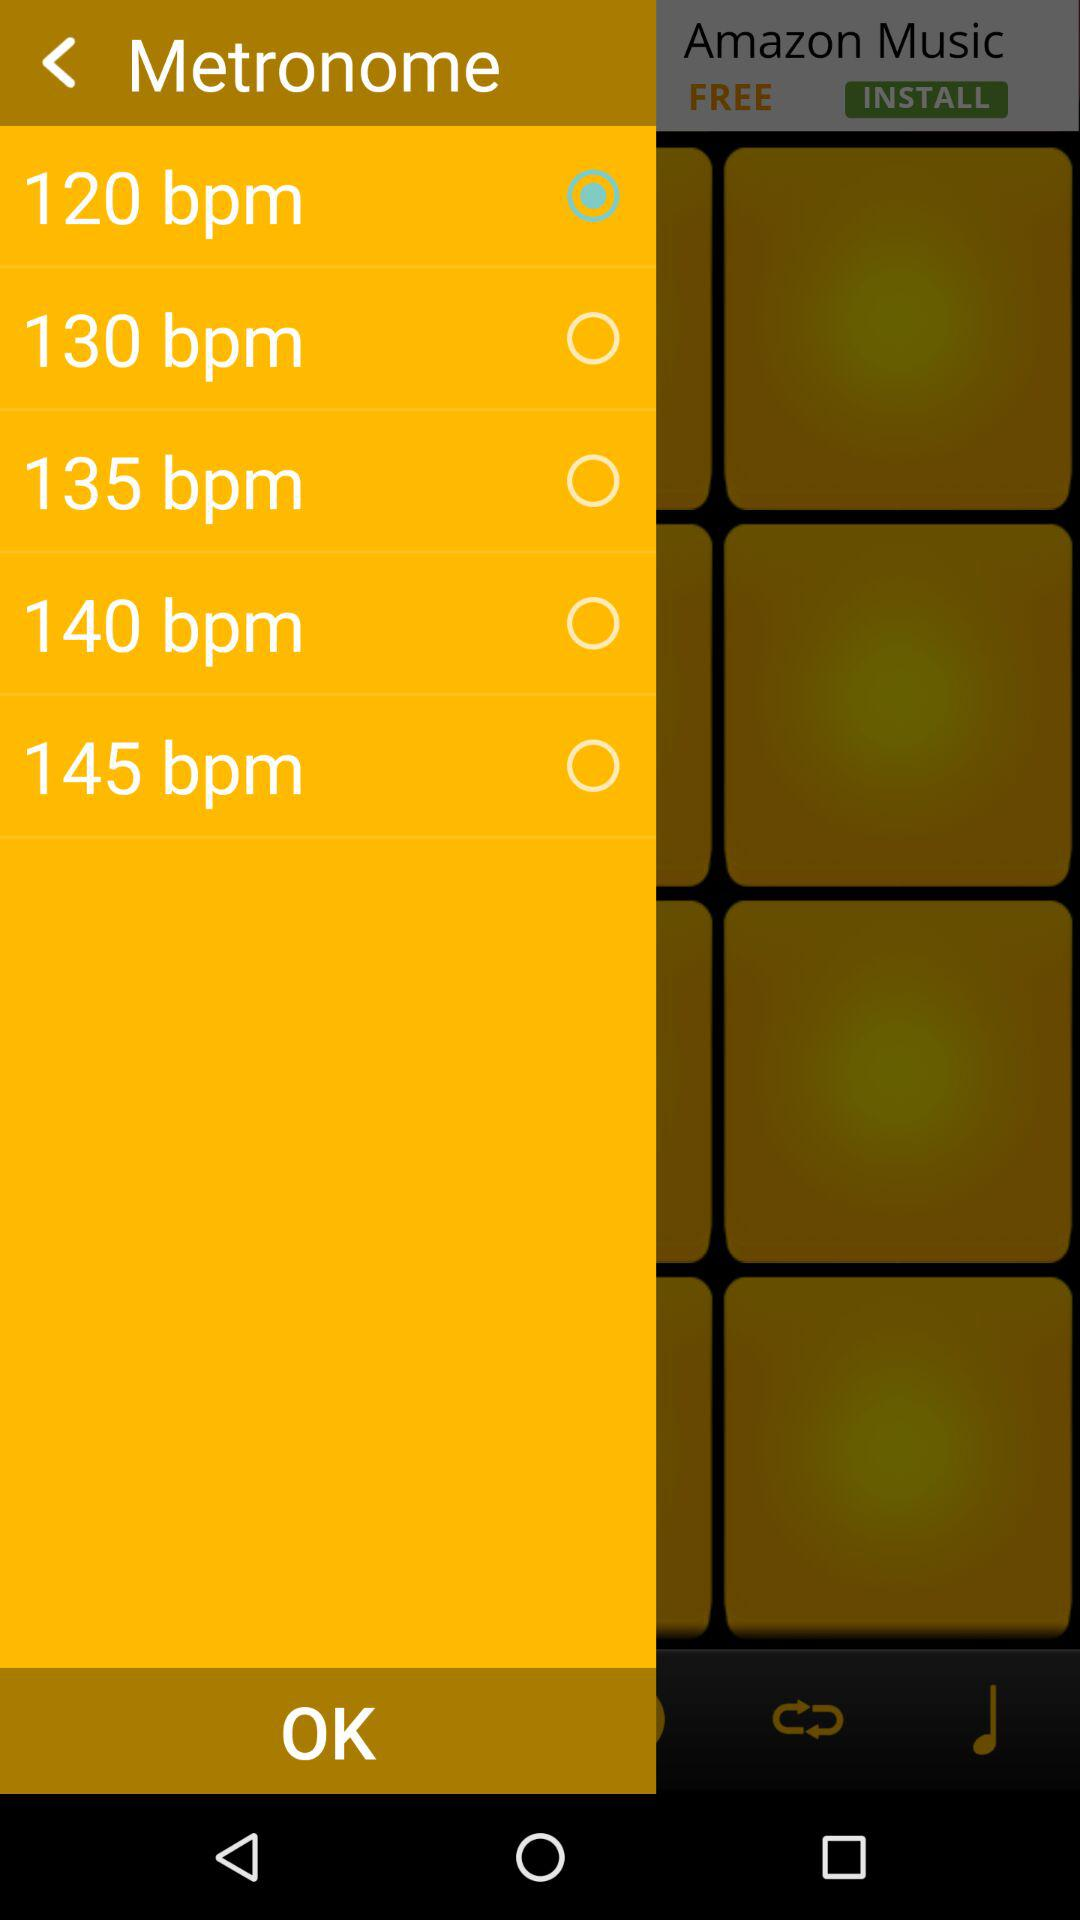How many bpm options are there?
Answer the question using a single word or phrase. 5 